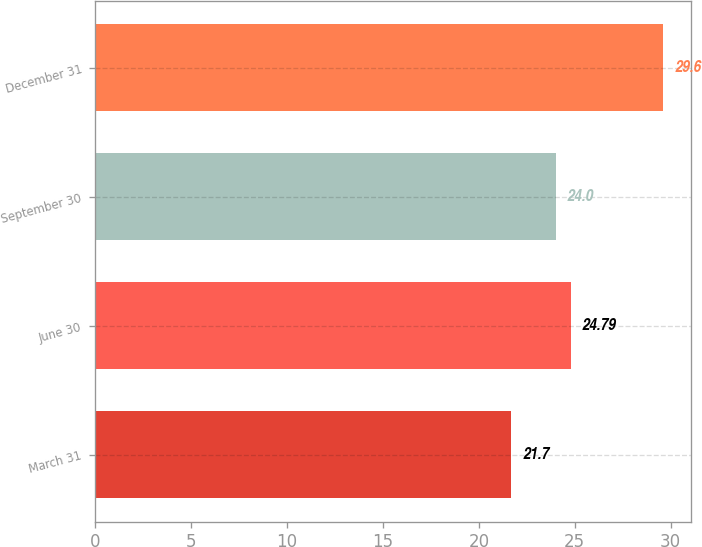Convert chart. <chart><loc_0><loc_0><loc_500><loc_500><bar_chart><fcel>March 31<fcel>June 30<fcel>September 30<fcel>December 31<nl><fcel>21.7<fcel>24.79<fcel>24<fcel>29.6<nl></chart> 